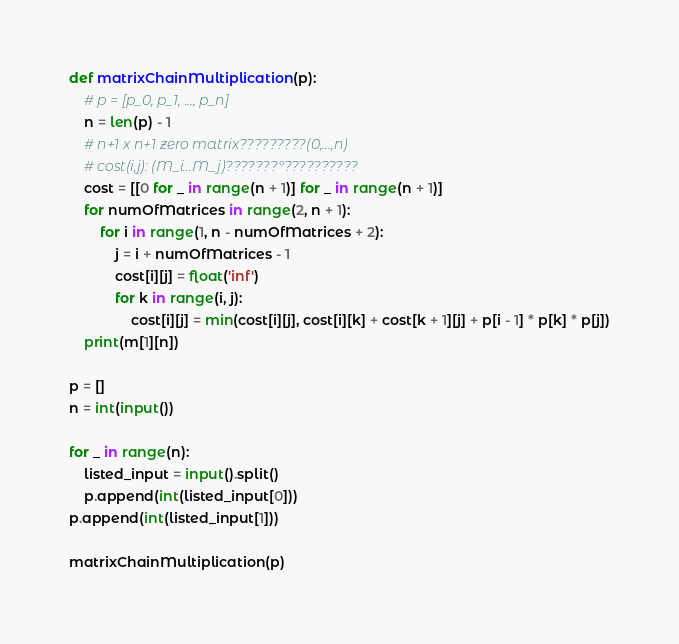Convert code to text. <code><loc_0><loc_0><loc_500><loc_500><_Python_>def matrixChainMultiplication(p):
    # p = [p_0, p_1, ..., p_n]
    n = len(p) - 1
    # n+1 x n+1 zero matrix?????????(0,...,n)
    # cost(i,j): (M_i...M_j)???????°??????????
    cost = [[0 for _ in range(n + 1)] for _ in range(n + 1)]
    for numOfMatrices in range(2, n + 1):
        for i in range(1, n - numOfMatrices + 2):
            j = i + numOfMatrices - 1
            cost[i][j] = float('inf')
            for k in range(i, j):
                cost[i][j] = min(cost[i][j], cost[i][k] + cost[k + 1][j] + p[i - 1] * p[k] * p[j])
    print(m[1][n])

p = []
n = int(input())

for _ in range(n):
    listed_input = input().split()
    p.append(int(listed_input[0]))
p.append(int(listed_input[1]))

matrixChainMultiplication(p)</code> 